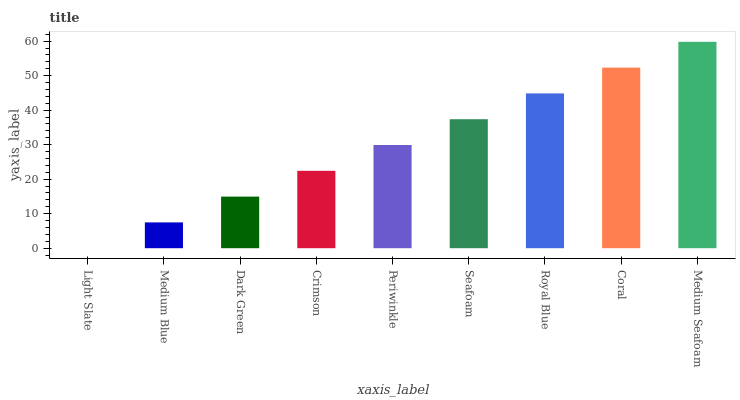Is Medium Blue the minimum?
Answer yes or no. No. Is Medium Blue the maximum?
Answer yes or no. No. Is Medium Blue greater than Light Slate?
Answer yes or no. Yes. Is Light Slate less than Medium Blue?
Answer yes or no. Yes. Is Light Slate greater than Medium Blue?
Answer yes or no. No. Is Medium Blue less than Light Slate?
Answer yes or no. No. Is Periwinkle the high median?
Answer yes or no. Yes. Is Periwinkle the low median?
Answer yes or no. Yes. Is Dark Green the high median?
Answer yes or no. No. Is Seafoam the low median?
Answer yes or no. No. 